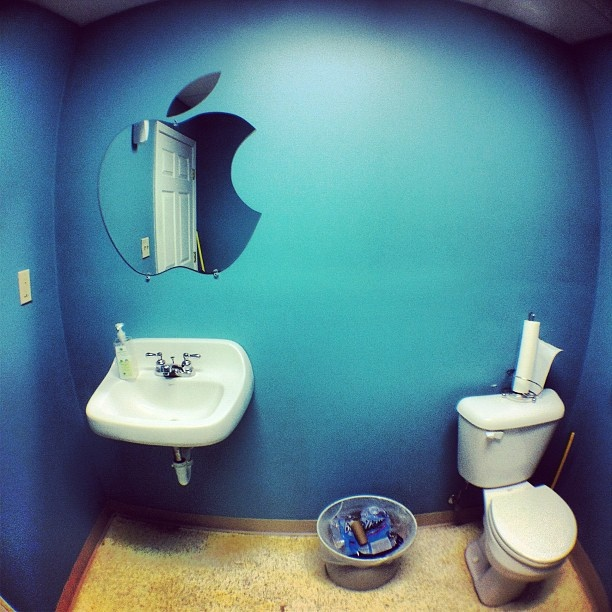Describe the objects in this image and their specific colors. I can see toilet in black, beige, darkgray, and gray tones and sink in black, beige, and darkgray tones in this image. 